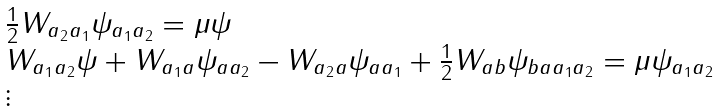<formula> <loc_0><loc_0><loc_500><loc_500>\begin{array} { l } \frac { 1 } { 2 } W _ { a _ { 2 } a _ { 1 } } \psi _ { a _ { 1 } a _ { 2 } } = \mu \psi \\ W _ { a _ { 1 } a _ { 2 } } \psi + W _ { a _ { 1 } a } \psi _ { a a _ { 2 } } - W _ { a _ { 2 } a } \psi _ { a a _ { 1 } } + \frac { 1 } { 2 } W _ { a b } \psi _ { b a a _ { 1 } a _ { 2 } } = \mu \psi _ { a _ { 1 } a _ { 2 } } \\ \vdots \end{array}</formula> 